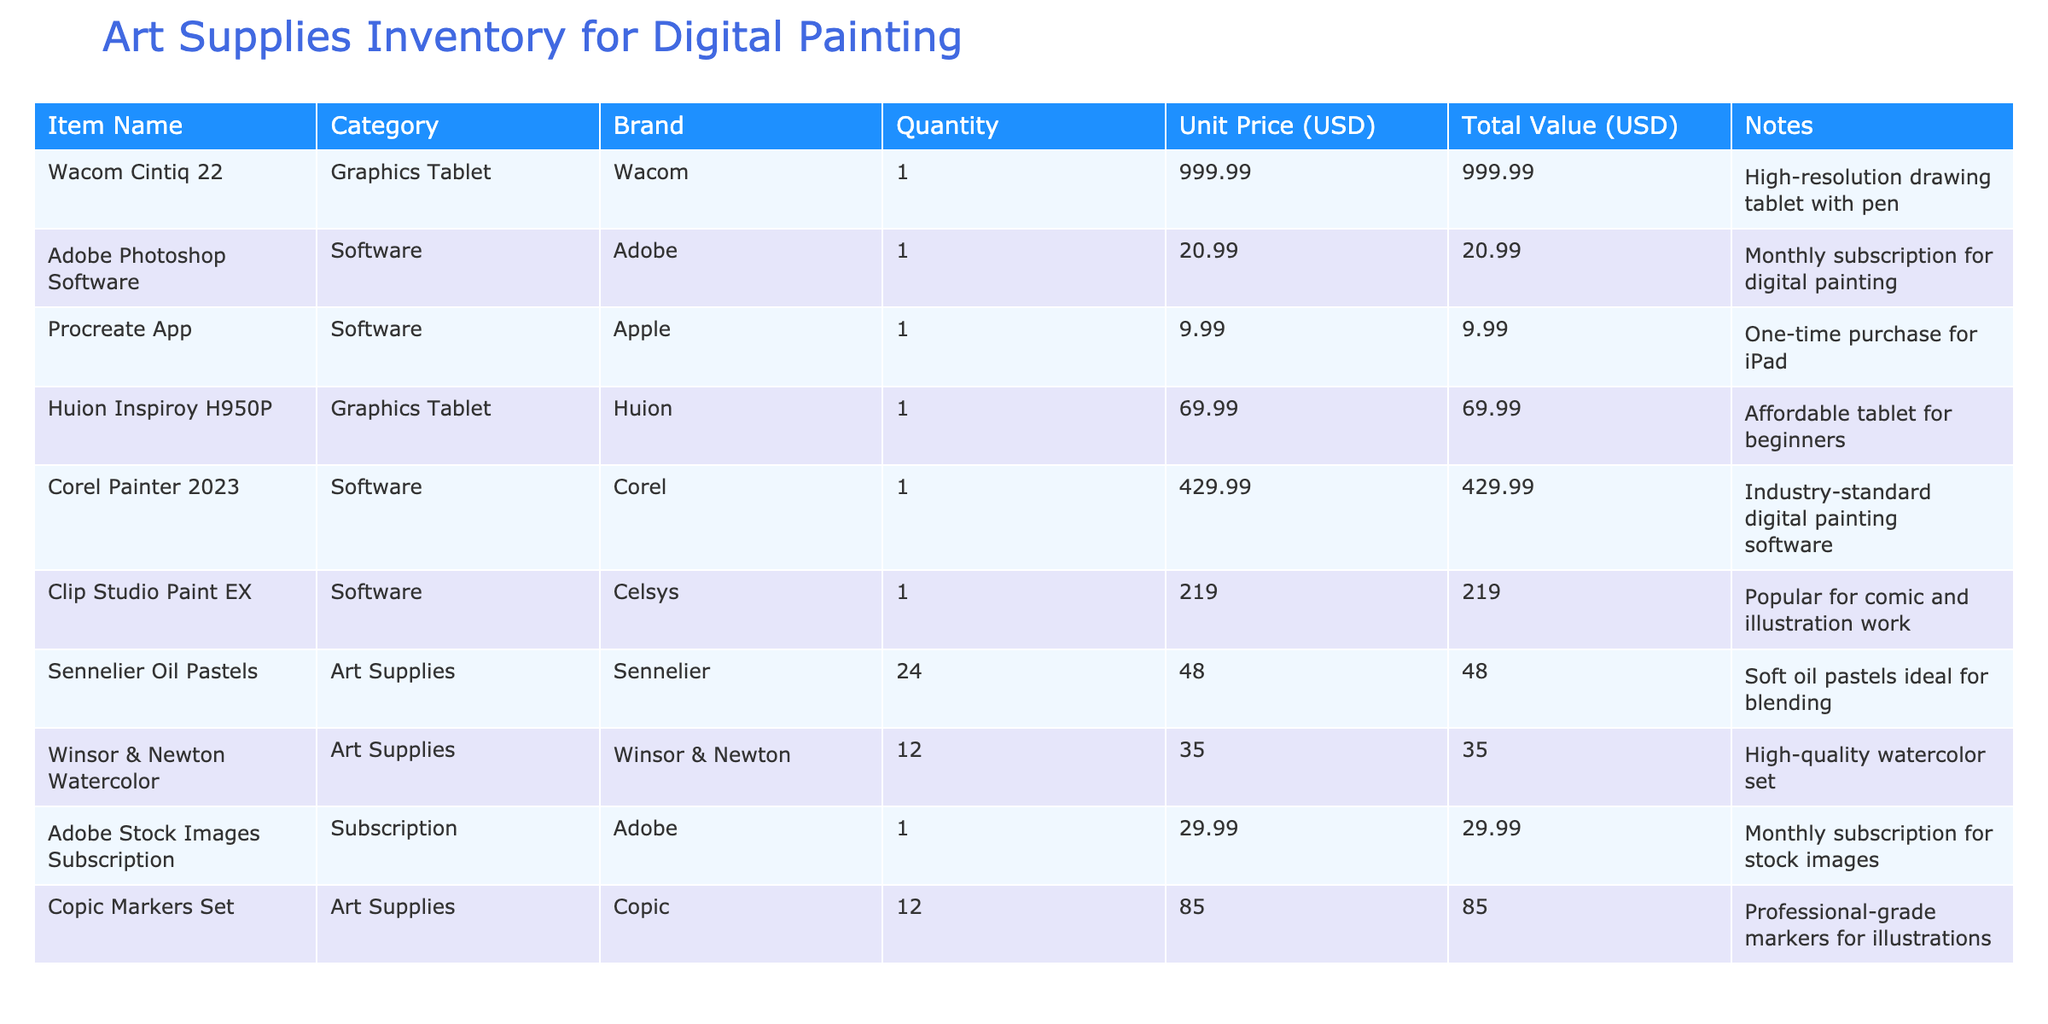What is the total quantity of graphic tablets listed? The table shows two graphic tablets: Wacom Cintiq 22 and Huion Inspiroy H950P. Both have a quantity of 1, so the total quantity is 1 + 1 = 2.
Answer: 2 How much does the Corel Painter 2023 software cost? The table lists the unit price of Corel Painter 2023 under the Software category as 429.99 USD.
Answer: 429.99 USD Are there any items from the brand Winsor & Newton in the inventory? The table lists Winsor & Newton under the Art Supplies category with a product: Winsor & Newton Watercolor, confirming that there is an item from this brand.
Answer: Yes What is the total value of all the art supplies available? The total values of Sennelier Oil Pastels (48.00 USD), Winsor & Newton Watercolor (35.00 USD), and Copic Markers Set (85.00 USD) are summed: 48.00 + 35.00 + 85.00 = 168.00 USD.
Answer: 168.00 USD Which software has the highest total value? Evaluating the total values: Adobe Photoshop Software (20.99 USD), Corel Painter 2023 (429.99 USD), Clip Studio Paint EX (219.00 USD), and Procreate App (9.99 USD), the highest value is Corel Painter 2023 amounting to 429.99 USD.
Answer: Corel Painter 2023 What is the average unit price of the art supplies? There are three art supplies: Sennelier Oil Pastels (48.00 USD), Winsor & Newton Watercolor (35.00 USD), and Copic Markers Set (85.00 USD). The average unit price is (48.00 + 35.00 + 85.00) / 3 = 56.00 USD.
Answer: 56.00 USD Which item has the lowest quantity in the table? By reviewing quantities, all items have a quantity of 1 except for Sennelier Oil Pastels, Winsor & Newton Watercolor, and Copic Markers Set which have 24, 12, and 12 respectively. Therefore, the lowest quantity is 1 for both Wacom Cintiq 22 and Huion Inspiroy H950P.
Answer: Wacom Cintiq 22 and Huion Inspiroy H950P Is the total value of the subscriptions greater than that of the software? The total value of subscriptions (Adobe Stock Images Subscription: 29.99 USD) is less than the total value of software (adding: Adobe Photoshop Software (20.99 USD), Corel Painter 2023 (429.99 USD), Clip Studio Paint EX (219.00 USD), and Procreate App (9.99 USD), giving a total of 680.96 USD), so it is false.
Answer: No 